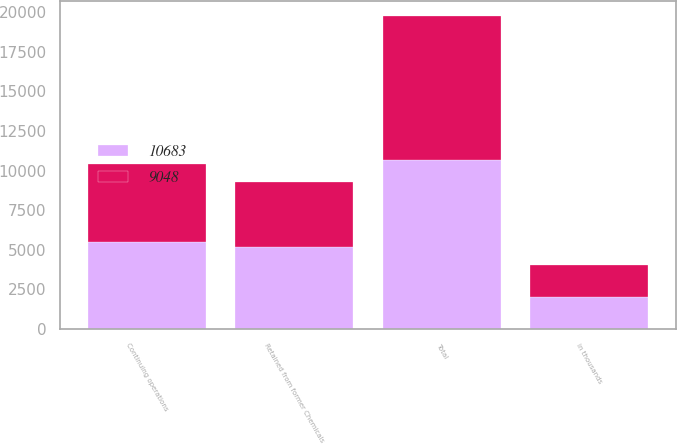<chart> <loc_0><loc_0><loc_500><loc_500><stacked_bar_chart><ecel><fcel>in thousands<fcel>Continuing operations<fcel>Retained from former Chemicals<fcel>Total<nl><fcel>9048<fcel>2014<fcel>4919<fcel>4129<fcel>9048<nl><fcel>10683<fcel>2013<fcel>5505<fcel>5178<fcel>10683<nl></chart> 